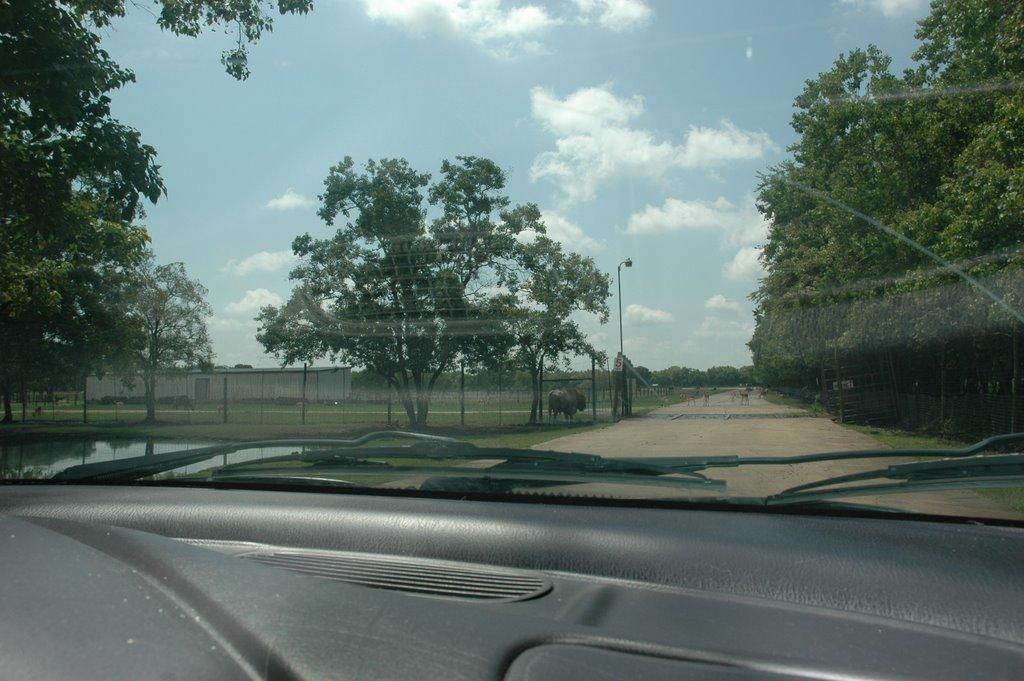What is the main object in the image? There is a car mirror in the image. What else can be seen inside the car? There is a dashboard and a wiper visible in the image. What can be seen in the background of the image? There are trees, a walkway, animals, fencing, and a sunny sky visible in the background of the image. What type of government is depicted in the image? There is no depiction of a government in the image; it features a car mirror, dashboard, wiper, and various background elements. What causes the burst of color in the image? There is no burst of color in the image; the colors are consistent and natural, with a sunny sky in the background. 